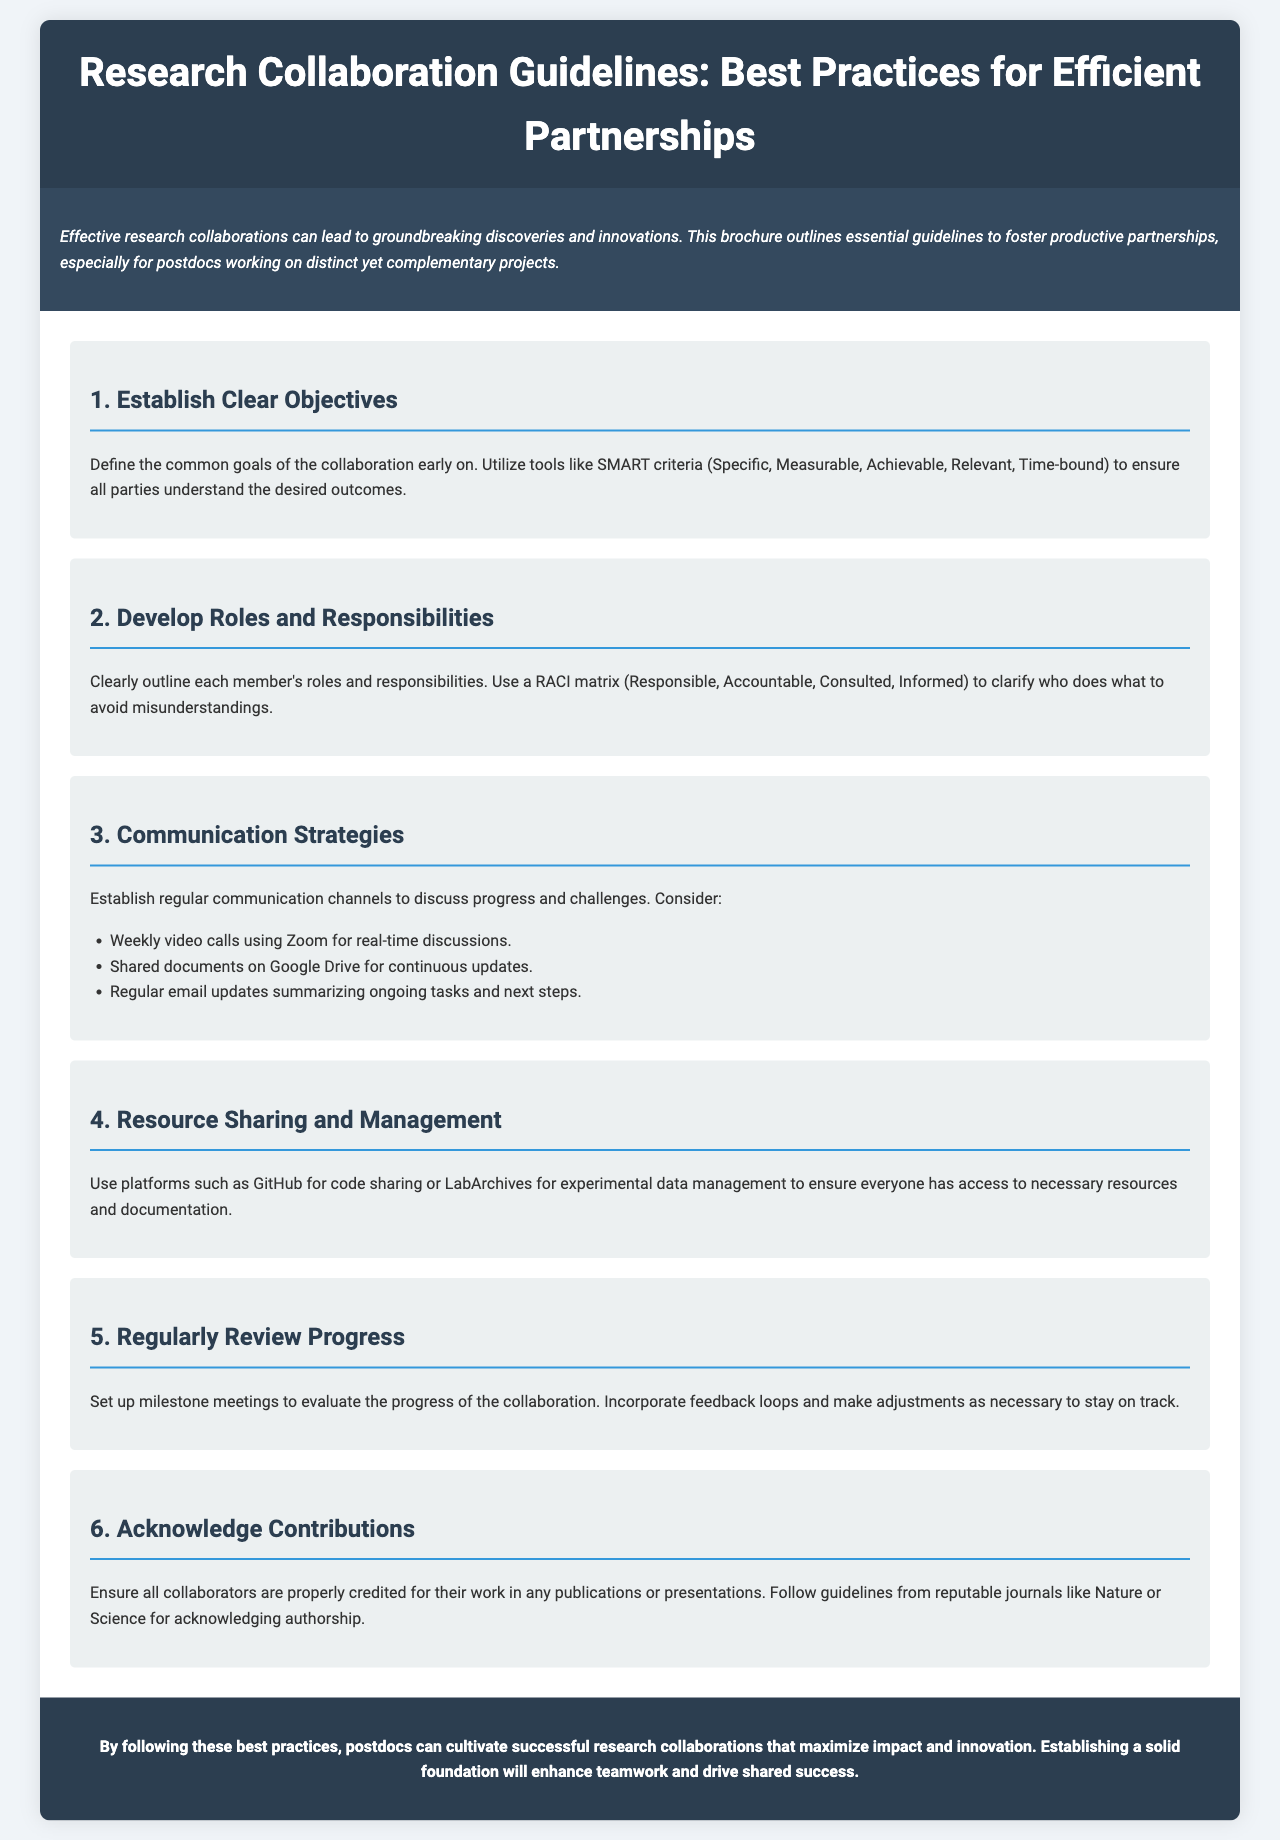What are the guidelines for research collaboration? The document outlines best practices for efficient partnerships in research collaboration.
Answer: Best practices for efficient partnerships What is one tool suggested for defining objectives? The document mentions using SMART criteria to define common goals.
Answer: SMART criteria What platform is recommended for resource sharing? GitHub is listed as a platform for code sharing in the document.
Answer: GitHub How often should progress be reviewed according to the guidelines? The document suggests setting up milestone meetings to evaluate progress regularly.
Answer: Regularly What should be established to avoid misunderstandings? The document indicates the importance of developing clear roles and responsibilities to avoid misunderstandings.
Answer: Clear roles and responsibilities Which communication tool is suggested for real-time discussions? Zoom is recommended for weekly video calls to facilitate communication.
Answer: Zoom Which type of matrix is suggested for outlining responsibilities? The document refers to a RACI matrix to clarify roles and responsibilities.
Answer: RACI matrix What is the purpose of acknowledging contributions? Properly crediting collaborators ensures recognition for their work in publications.
Answer: Recognition for their work What is a recommended strategy for ongoing updates? Shared documents on Google Drive are recommended for continuous updates.
Answer: Google Drive 